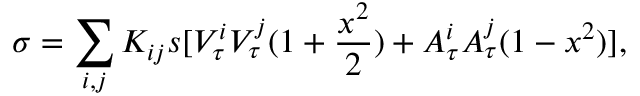Convert formula to latex. <formula><loc_0><loc_0><loc_500><loc_500>\sigma = \sum _ { i , j } K _ { i j } s [ V _ { \tau } ^ { i } V _ { \tau } ^ { j } ( 1 + \frac { x ^ { 2 } } { 2 } ) + A _ { \tau } ^ { i } A _ { \tau } ^ { j } ( 1 - x ^ { 2 } ) ] ,</formula> 